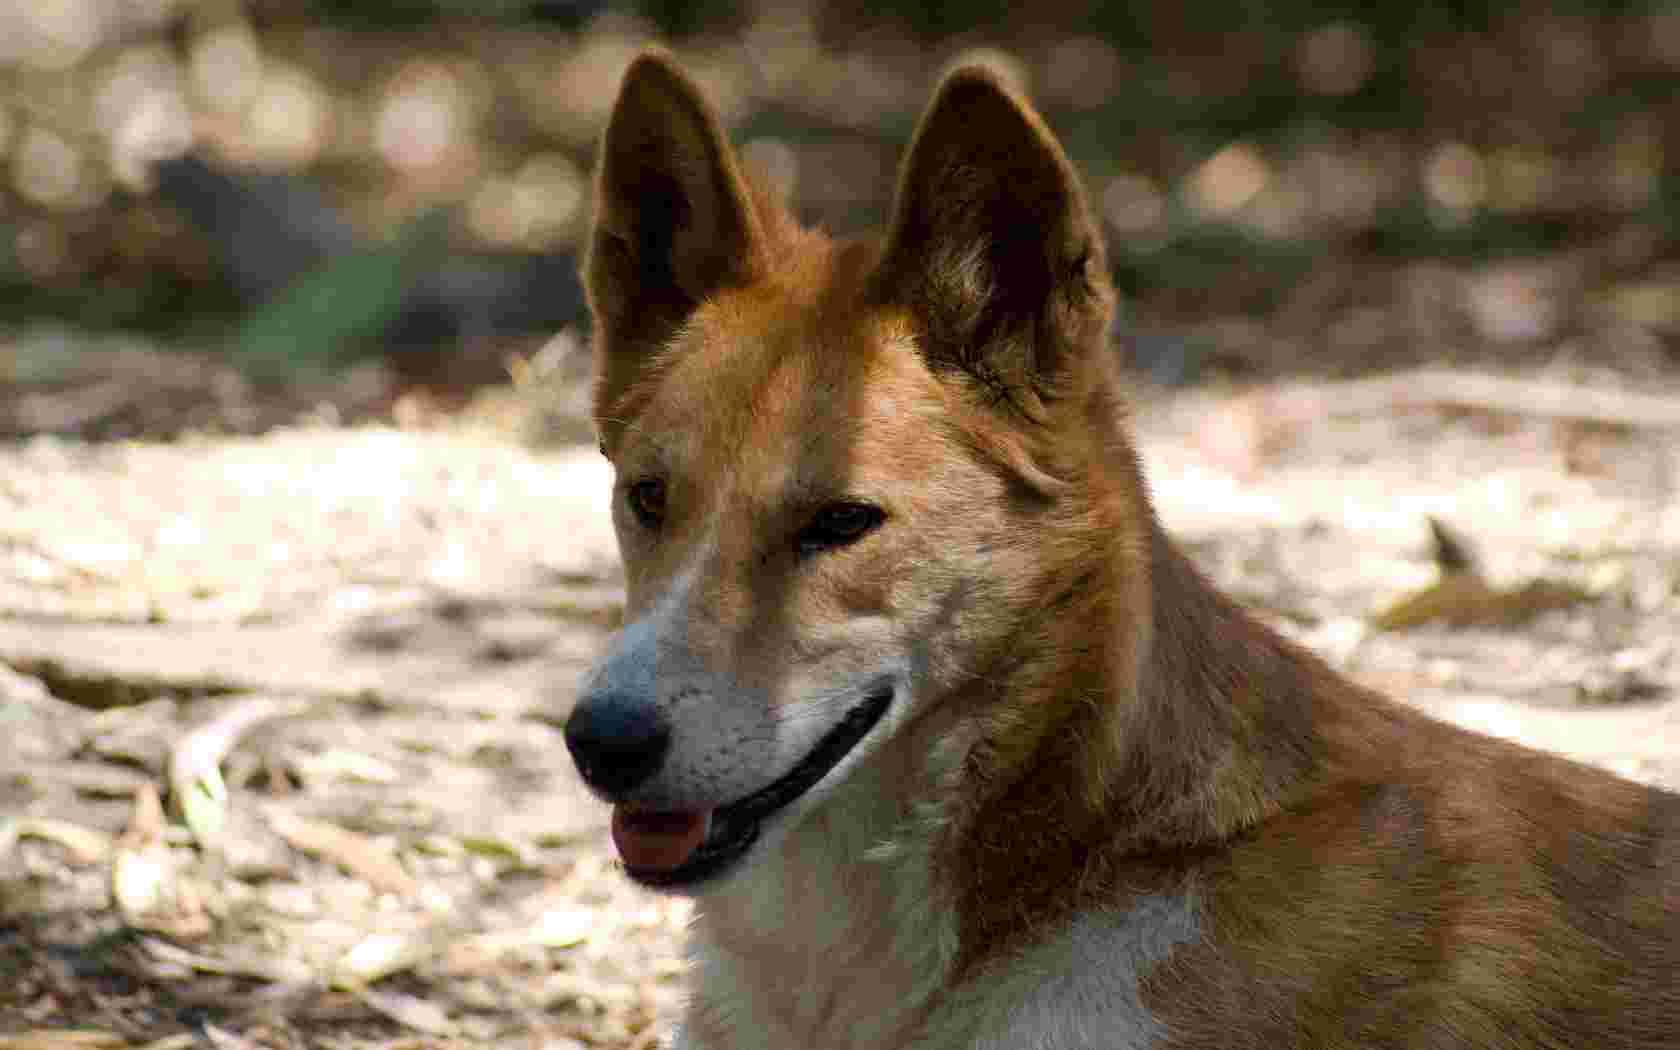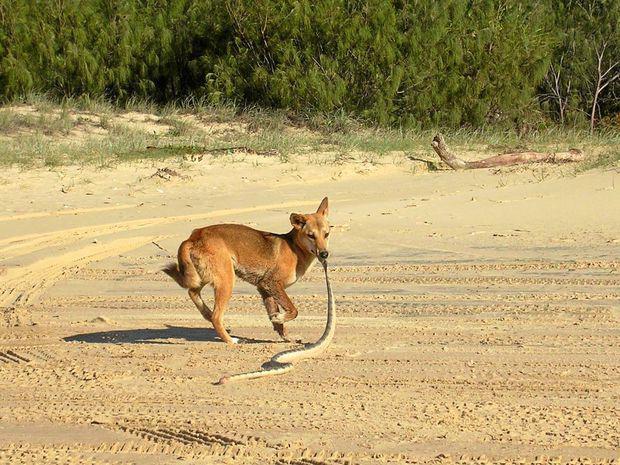The first image is the image on the left, the second image is the image on the right. Examine the images to the left and right. Is the description "There is a dog dragging a snake over sand." accurate? Answer yes or no. Yes. 